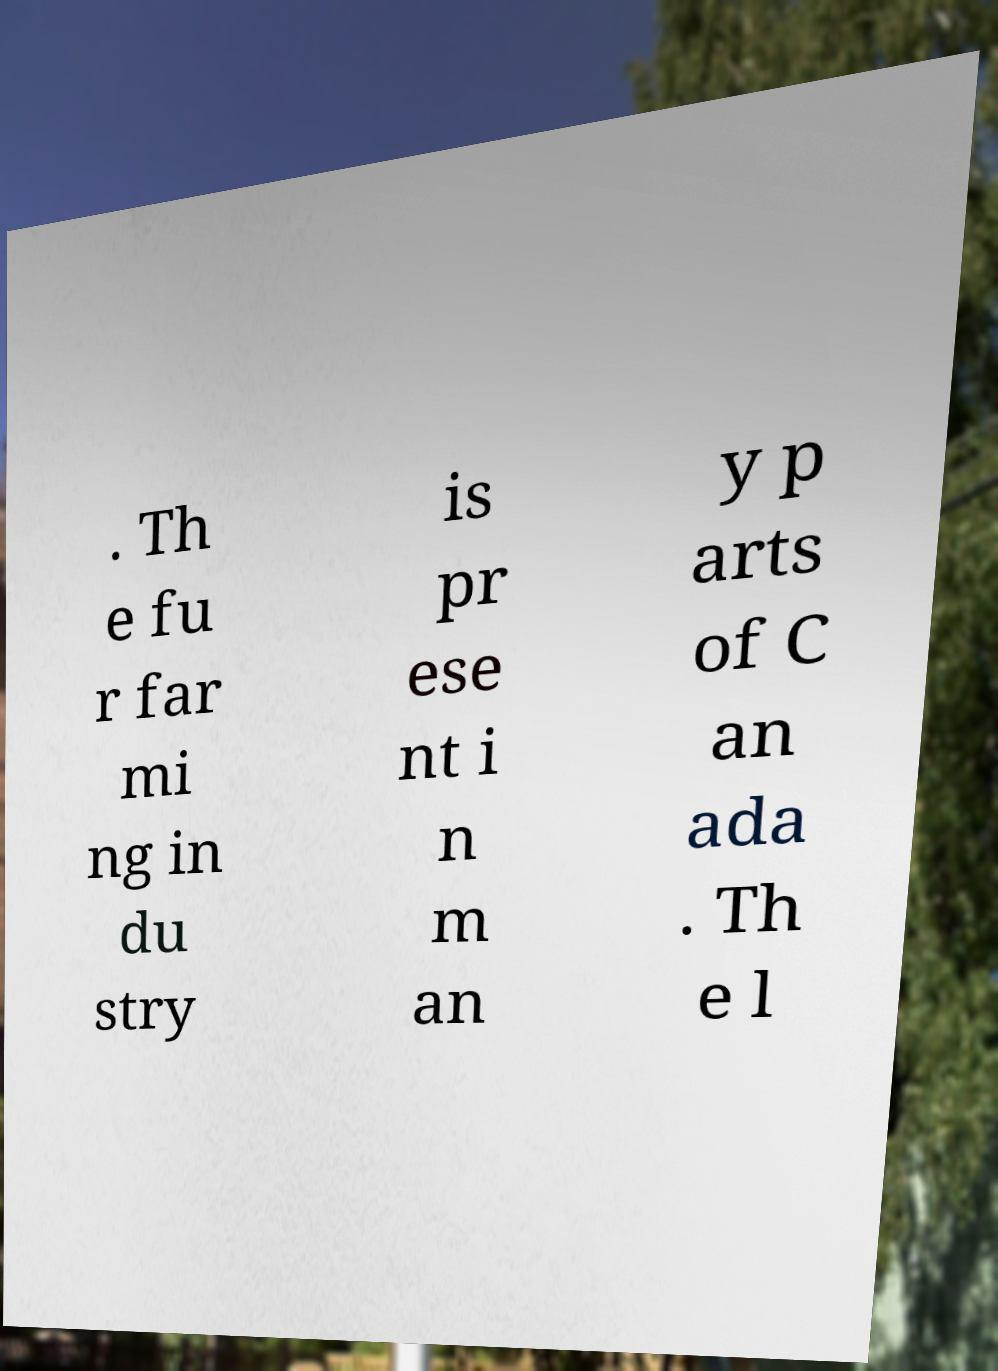Please read and relay the text visible in this image. What does it say? . Th e fu r far mi ng in du stry is pr ese nt i n m an y p arts of C an ada . Th e l 